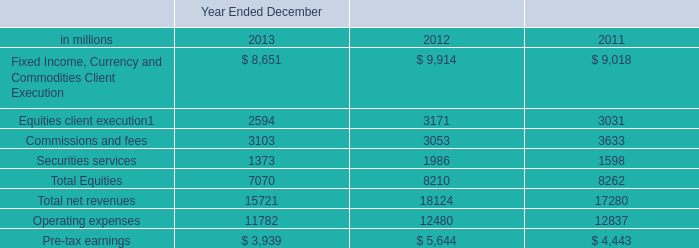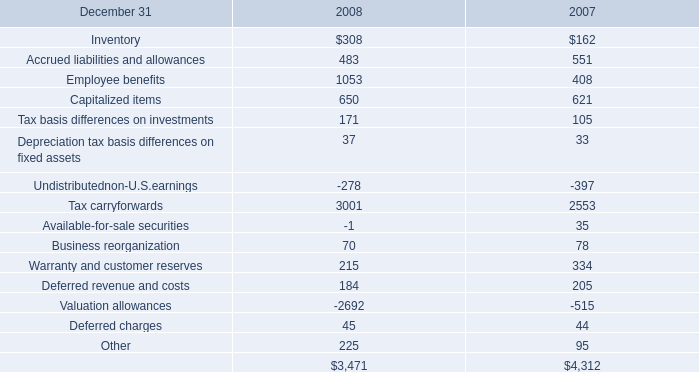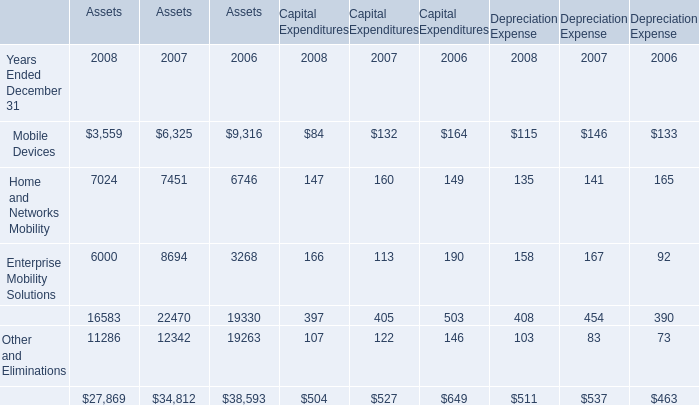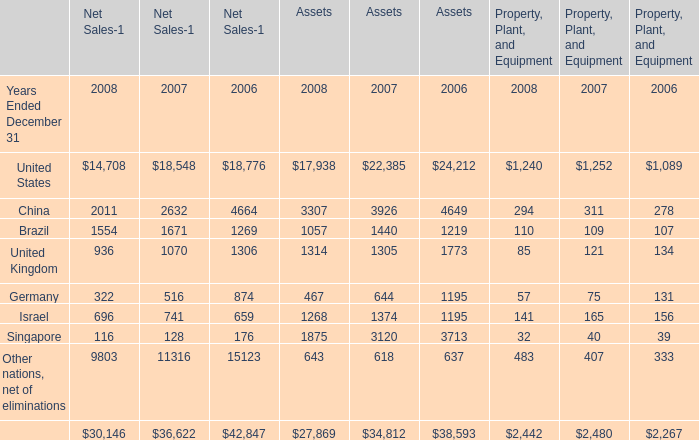what's the total amount of Commissions and fees of Year Ended December 2011, and Home and Networks Mobility of Assets ? 
Computations: (3633.0 + 7024.0)
Answer: 10657.0. 